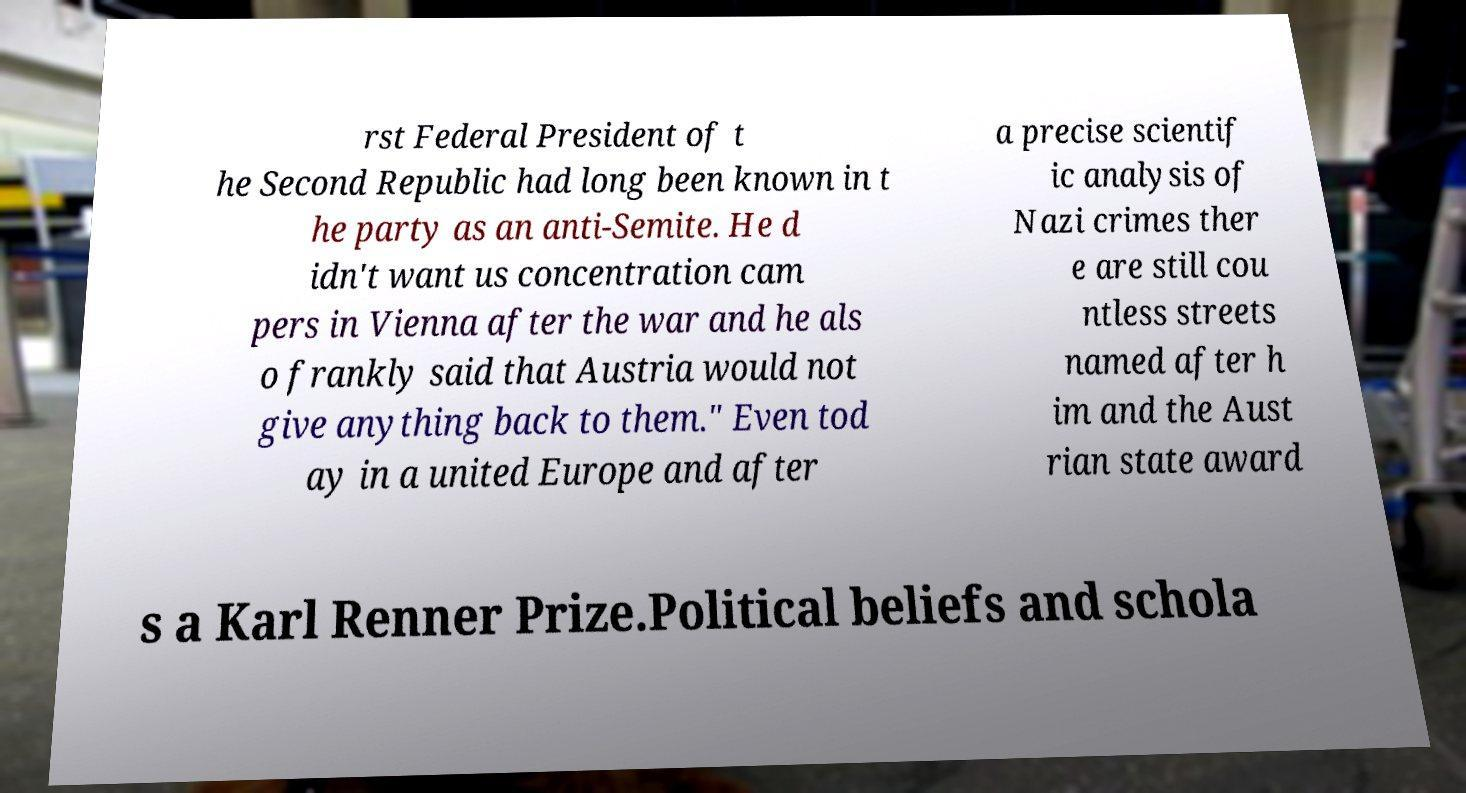Could you assist in decoding the text presented in this image and type it out clearly? rst Federal President of t he Second Republic had long been known in t he party as an anti-Semite. He d idn't want us concentration cam pers in Vienna after the war and he als o frankly said that Austria would not give anything back to them." Even tod ay in a united Europe and after a precise scientif ic analysis of Nazi crimes ther e are still cou ntless streets named after h im and the Aust rian state award s a Karl Renner Prize.Political beliefs and schola 